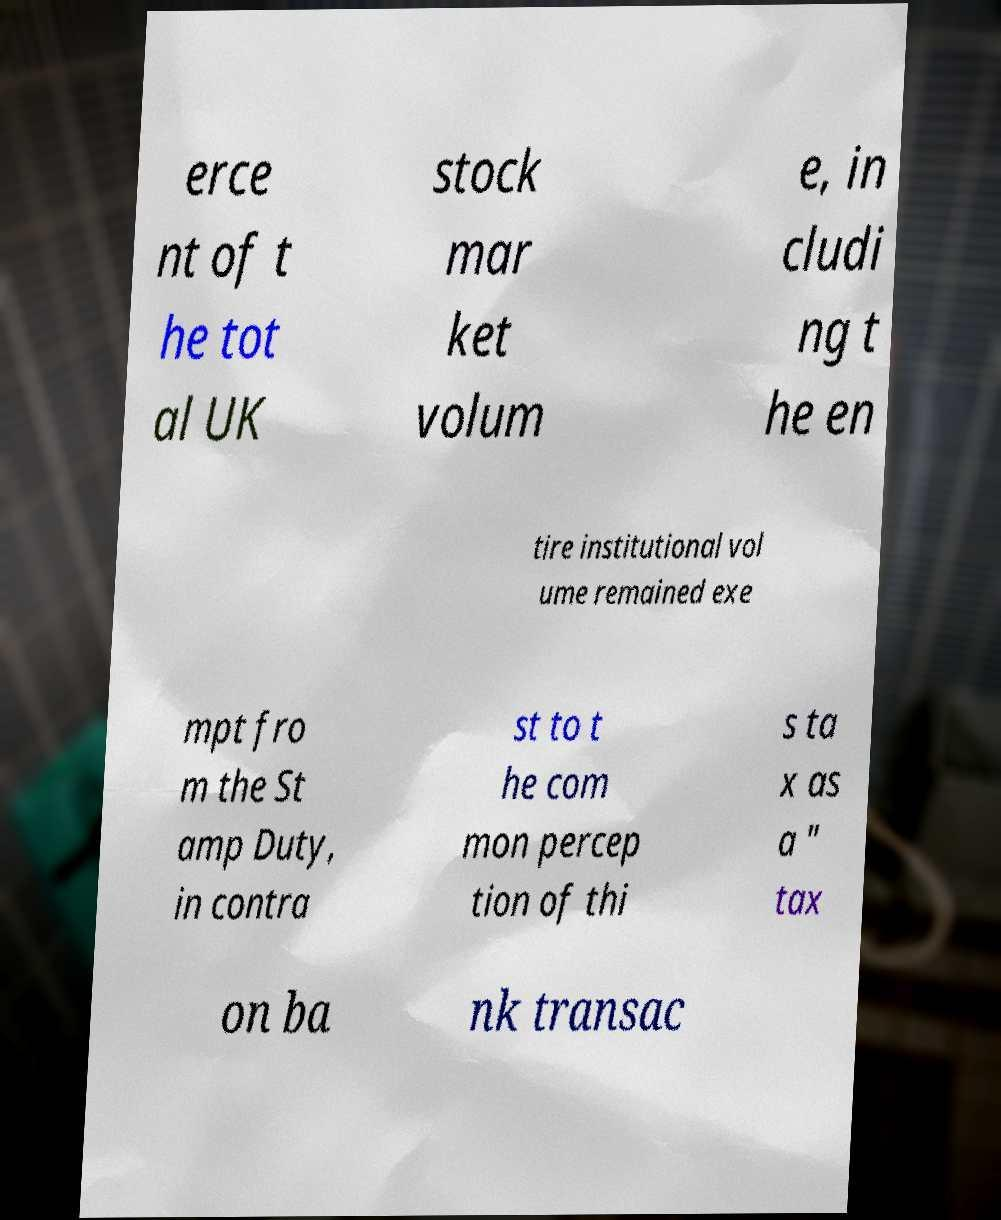I need the written content from this picture converted into text. Can you do that? erce nt of t he tot al UK stock mar ket volum e, in cludi ng t he en tire institutional vol ume remained exe mpt fro m the St amp Duty, in contra st to t he com mon percep tion of thi s ta x as a " tax on ba nk transac 